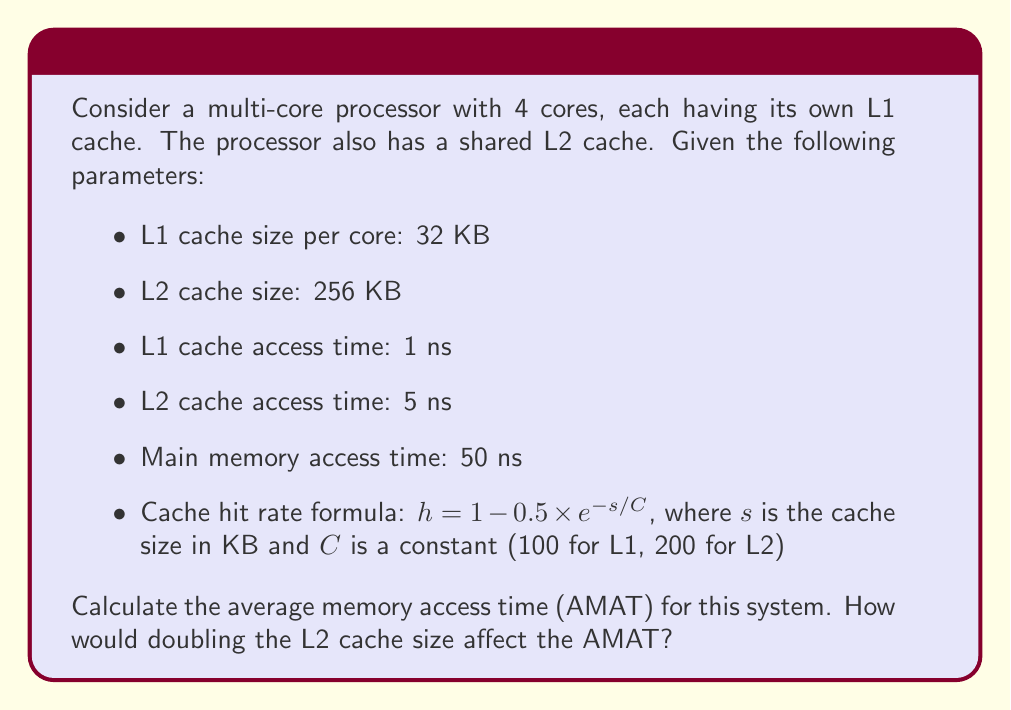Provide a solution to this math problem. Let's approach this step-by-step:

1. Calculate the hit rates for L1 and L2 caches:
   L1 hit rate: $h_{L1} = 1 - 0.5 \times e^{-32/100} = 1 - 0.5 \times e^{-0.32} \approx 0.8639$
   L2 hit rate: $h_{L2} = 1 - 0.5 \times e^{-256/200} = 1 - 0.5 \times e^{-1.28} \approx 0.9594$

2. Calculate the miss rates:
   L1 miss rate: $m_{L1} = 1 - h_{L1} \approx 0.1361$
   L2 miss rate: $m_{L2} = 1 - h_{L2} \approx 0.0406$

3. Calculate the AMAT using the formula:
   $AMAT = T_{L1} + m_{L1} \times (T_{L2} + m_{L2} \times T_{MM})$
   Where $T_{L1}$, $T_{L2}$, and $T_{MM}$ are the access times for L1, L2, and main memory respectively.

   $AMAT = 1 + 0.1361 \times (5 + 0.0406 \times 50)$
   $AMAT = 1 + 0.1361 \times (5 + 2.03)$
   $AMAT = 1 + 0.1361 \times 7.03$
   $AMAT \approx 1.9567$ ns

4. Now, let's calculate the AMAT with doubled L2 cache size (512 KB):
   New L2 hit rate: $h_{L2_{new}} = 1 - 0.5 \times e^{-512/200} \approx 0.9843$
   New L2 miss rate: $m_{L2_{new}} = 1 - 0.9843 \approx 0.0157$

   $AMAT_{new} = 1 + 0.1361 \times (5 + 0.0157 \times 50)$
   $AMAT_{new} = 1 + 0.1361 \times (5 + 0.785)$
   $AMAT_{new} = 1 + 0.1361 \times 5.785$
   $AMAT_{new} \approx 1.7872$ ns

5. The improvement in AMAT:
   $\Delta AMAT = AMAT - AMAT_{new} \approx 1.9567 - 1.7872 = 0.1695$ ns
   Percentage improvement: $\frac{0.1695}{1.9567} \times 100\% \approx 8.66\%$
Answer: Doubling the L2 cache size reduces AMAT by approximately 0.1695 ns (8.66% improvement). 